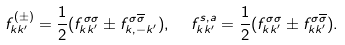Convert formula to latex. <formula><loc_0><loc_0><loc_500><loc_500>f ^ { ( \pm ) } _ { k k ^ { \prime } } = \frac { 1 } { 2 } ( f ^ { \sigma \sigma } _ { k k ^ { \prime } } \pm f ^ { \sigma \overline { \sigma } } _ { k , - k ^ { \prime } } ) , \ \ f ^ { s , a } _ { k k ^ { \prime } } = \frac { 1 } { 2 } ( f ^ { \sigma \sigma } _ { k k ^ { \prime } } \pm f ^ { \sigma \overline { \sigma } } _ { k k ^ { \prime } } ) .</formula> 